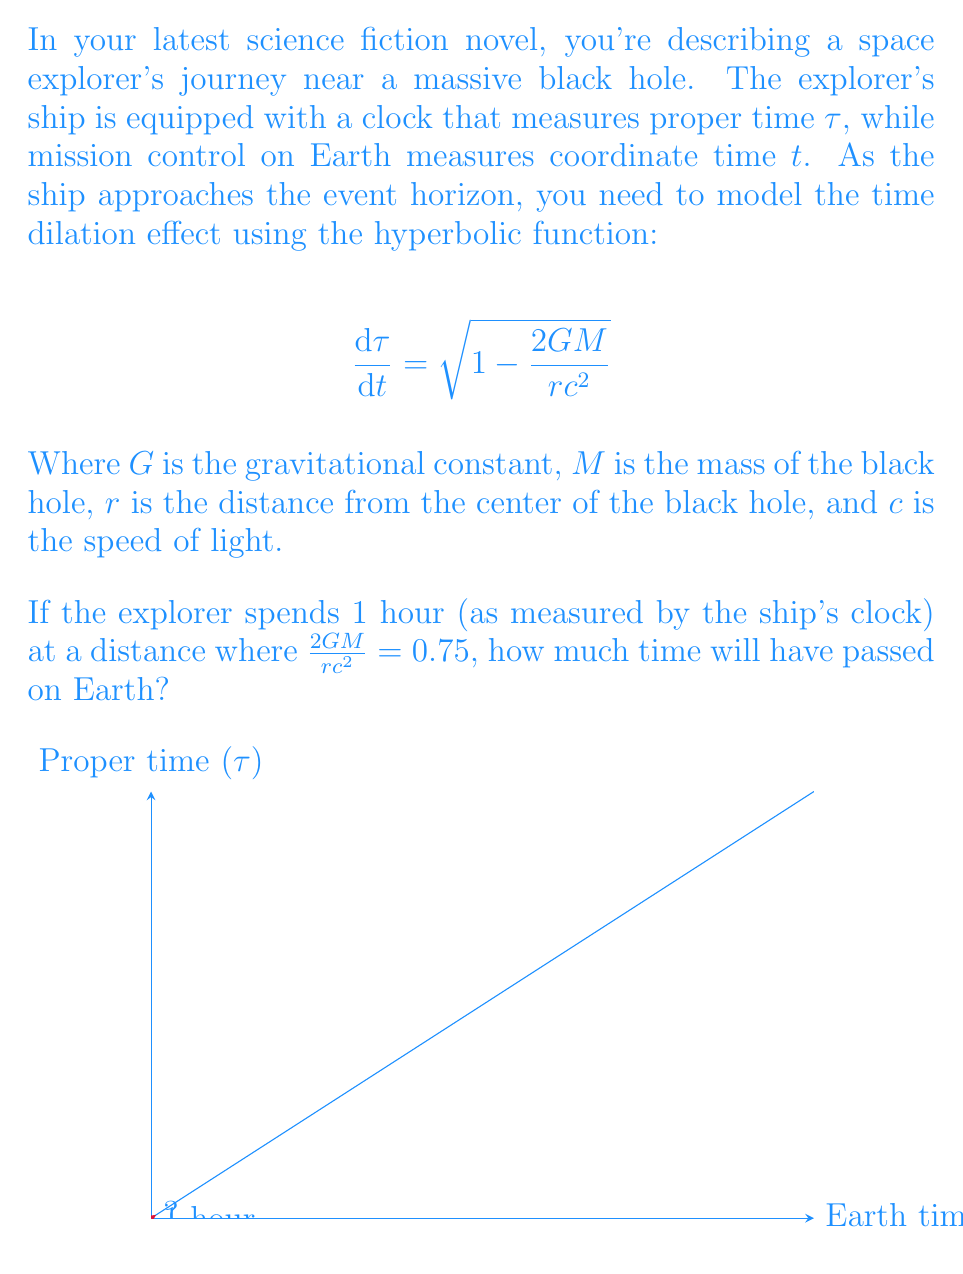Help me with this question. Let's approach this step-by-step:

1) We're given the equation for time dilation:

   $$\frac{d\tau}{dt} = \sqrt{1 - \frac{2GM}{rc^2}}$$

2) We're told that $\frac{2GM}{rc^2} = 0.75$. Let's substitute this into our equation:

   $$\frac{d\tau}{dt} = \sqrt{1 - 0.75} = \sqrt{0.25} = 0.5$$

3) This means that for every unit of coordinate time (t) that passes on Earth, only 0.5 units of proper time ($\tau$) pass on the ship.

4) We can rewrite this as:

   $$dt = \frac{d\tau}{0.5}$$

5) The explorer spends 1 hour according to the ship's clock. So $d\tau = 1$ hour.

6) Substituting this into our equation:

   $$dt = \frac{1}{0.5} = 2$$

7) Therefore, 2 hours will pass on Earth for every 1 hour that passes on the ship.
Answer: 2 hours 